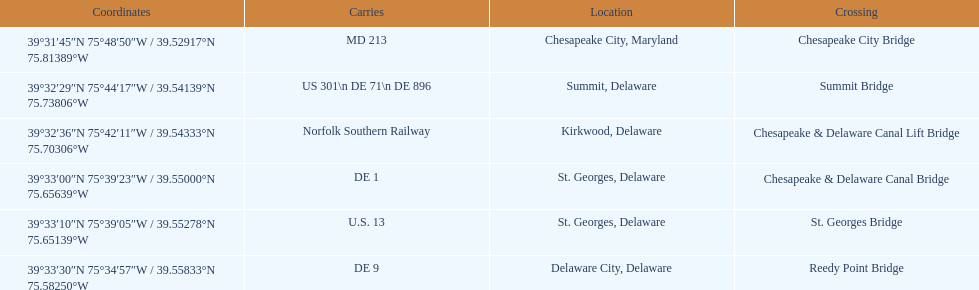Which bridge has their location in summit, delaware? Summit Bridge. 